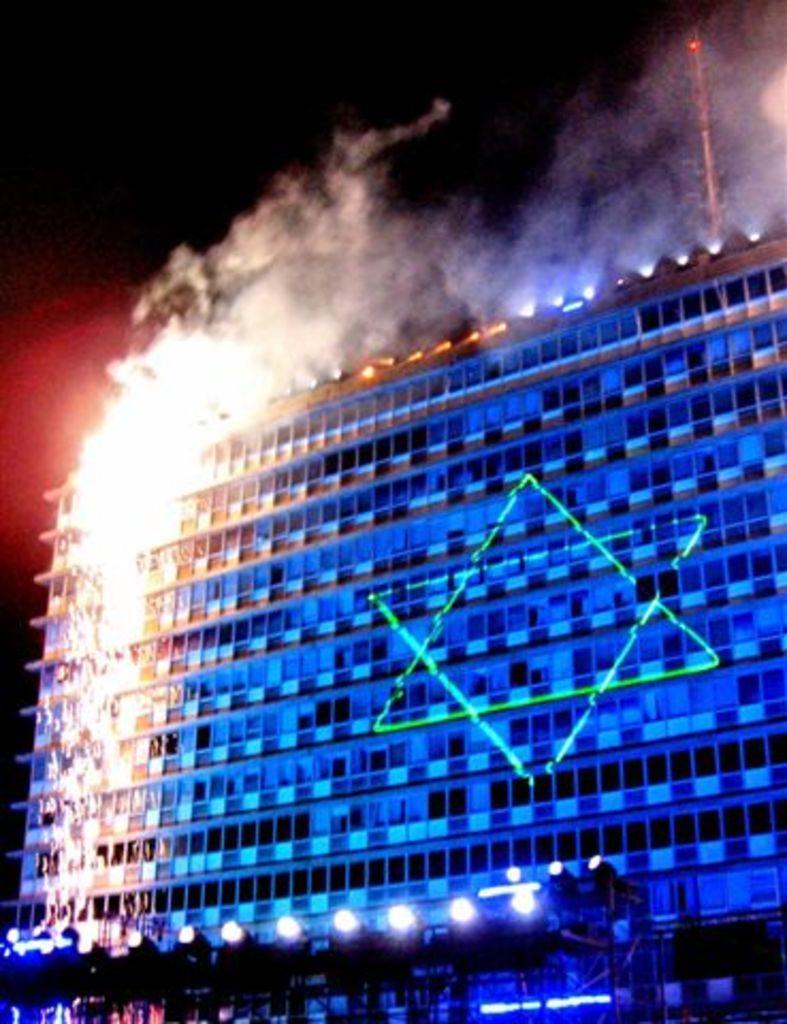Could you give a brief overview of what you see in this image? In this image I can see a building and in the front of it I can see number of lights. I can also see smoke and a tower on the top side of this image. 